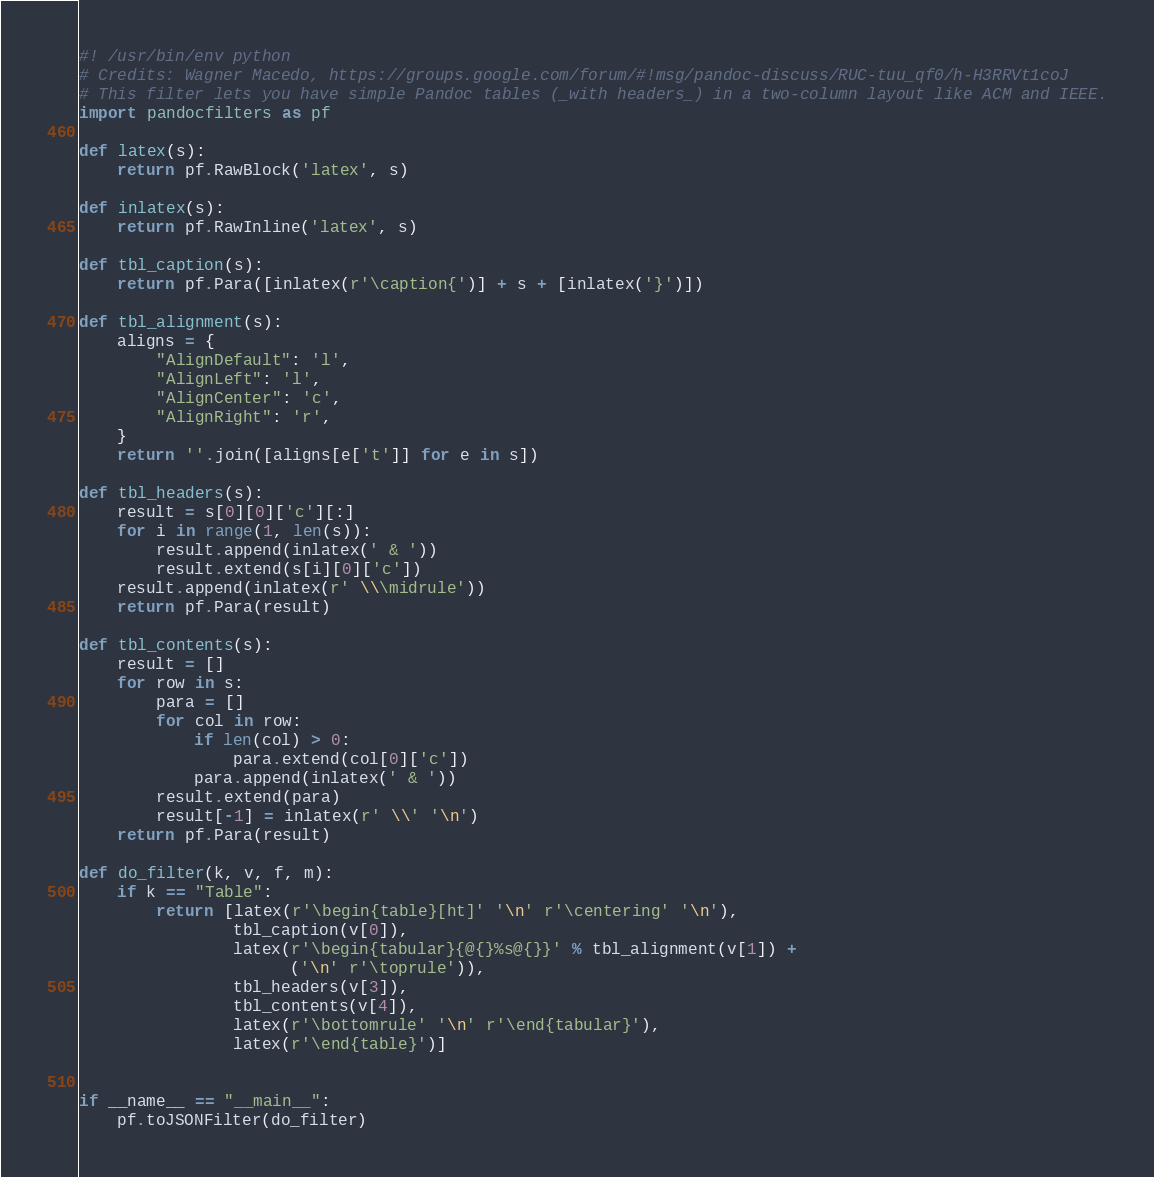<code> <loc_0><loc_0><loc_500><loc_500><_Python_>#! /usr/bin/env python
# Credits: Wagner Macedo, https://groups.google.com/forum/#!msg/pandoc-discuss/RUC-tuu_qf0/h-H3RRVt1coJ
# This filter lets you have simple Pandoc tables (_with headers_) in a two-column layout like ACM and IEEE.
import pandocfilters as pf

def latex(s):
    return pf.RawBlock('latex', s)

def inlatex(s):
    return pf.RawInline('latex', s)

def tbl_caption(s):
    return pf.Para([inlatex(r'\caption{')] + s + [inlatex('}')])

def tbl_alignment(s):
    aligns = {
        "AlignDefault": 'l',
        "AlignLeft": 'l',
        "AlignCenter": 'c',
        "AlignRight": 'r',
    }
    return ''.join([aligns[e['t']] for e in s])

def tbl_headers(s):
    result = s[0][0]['c'][:]
    for i in range(1, len(s)):
        result.append(inlatex(' & '))
        result.extend(s[i][0]['c'])
    result.append(inlatex(r' \\\midrule'))
    return pf.Para(result)

def tbl_contents(s):
    result = []
    for row in s:
        para = []
        for col in row:
            if len(col) > 0:
                para.extend(col[0]['c'])
            para.append(inlatex(' & '))
        result.extend(para)
        result[-1] = inlatex(r' \\' '\n')
    return pf.Para(result)

def do_filter(k, v, f, m):
    if k == "Table":
        return [latex(r'\begin{table}[ht]' '\n' r'\centering' '\n'),
                tbl_caption(v[0]),
                latex(r'\begin{tabular}{@{}%s@{}}' % tbl_alignment(v[1]) +
                      ('\n' r'\toprule')),
                tbl_headers(v[3]),
                tbl_contents(v[4]),
                latex(r'\bottomrule' '\n' r'\end{tabular}'),
                latex(r'\end{table}')]


if __name__ == "__main__":
    pf.toJSONFilter(do_filter)
</code> 